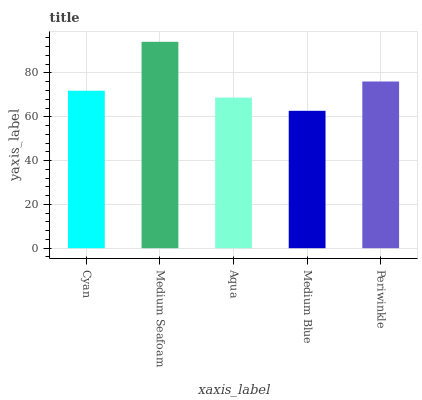Is Medium Blue the minimum?
Answer yes or no. Yes. Is Medium Seafoam the maximum?
Answer yes or no. Yes. Is Aqua the minimum?
Answer yes or no. No. Is Aqua the maximum?
Answer yes or no. No. Is Medium Seafoam greater than Aqua?
Answer yes or no. Yes. Is Aqua less than Medium Seafoam?
Answer yes or no. Yes. Is Aqua greater than Medium Seafoam?
Answer yes or no. No. Is Medium Seafoam less than Aqua?
Answer yes or no. No. Is Cyan the high median?
Answer yes or no. Yes. Is Cyan the low median?
Answer yes or no. Yes. Is Medium Blue the high median?
Answer yes or no. No. Is Aqua the low median?
Answer yes or no. No. 